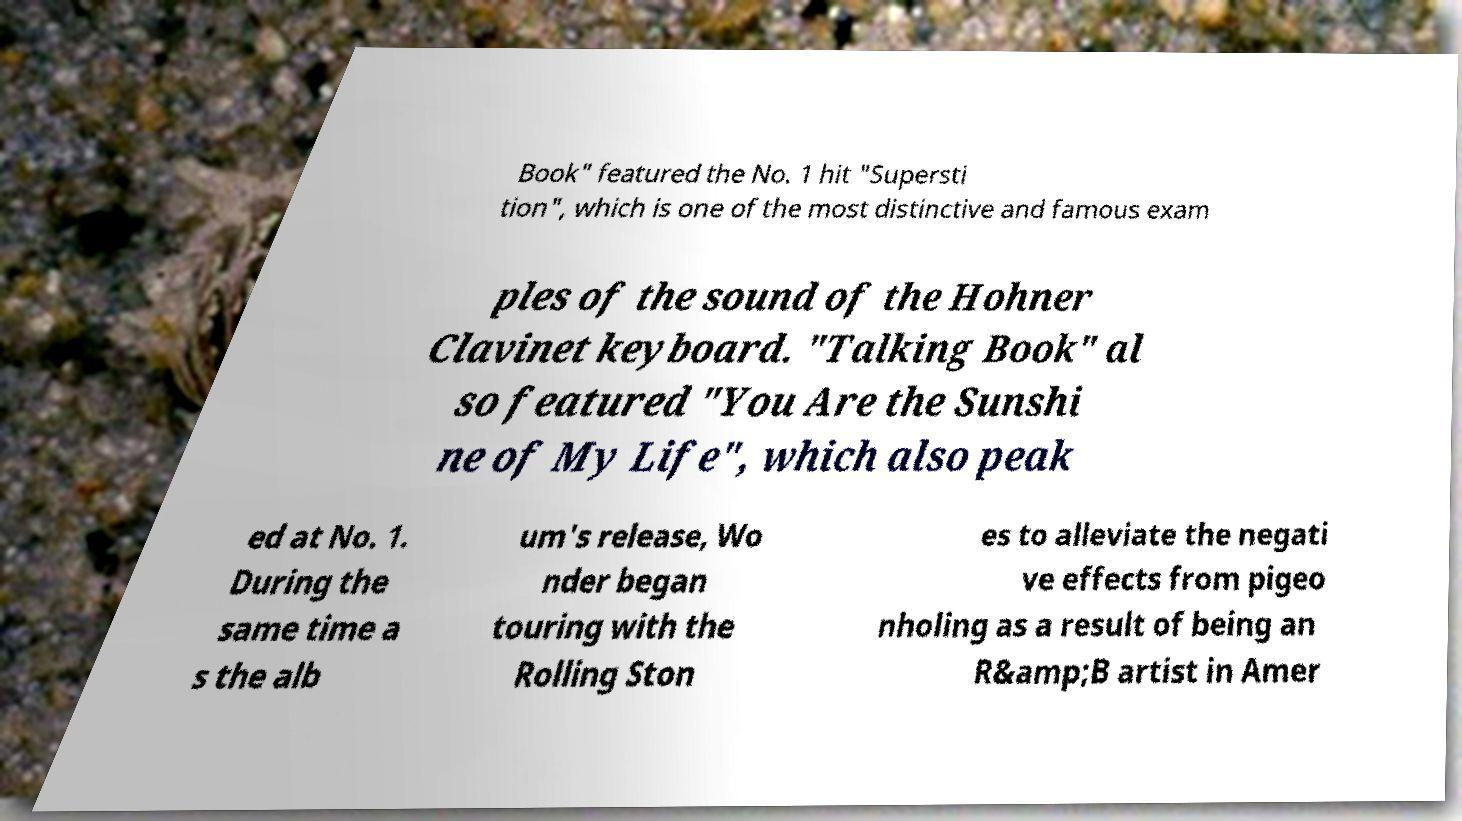Could you extract and type out the text from this image? Book" featured the No. 1 hit "Supersti tion", which is one of the most distinctive and famous exam ples of the sound of the Hohner Clavinet keyboard. "Talking Book" al so featured "You Are the Sunshi ne of My Life", which also peak ed at No. 1. During the same time a s the alb um's release, Wo nder began touring with the Rolling Ston es to alleviate the negati ve effects from pigeo nholing as a result of being an R&amp;B artist in Amer 